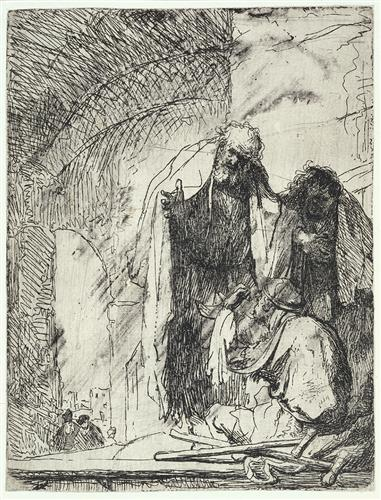What might be the story or event depicted in this etching? While the specific event is not immediately identifiable without context, the etching likely represents a scene from a religious narrative, given the solemn postures and classical attire of the figures. It may depict a moment of lamentation or mourning from a biblical tale, such as the death of a prophet or saint. The clothing suggests an ancient setting, possibly linking the story to religious texts that have inspired countless artists to capture their most dramatic moments. 